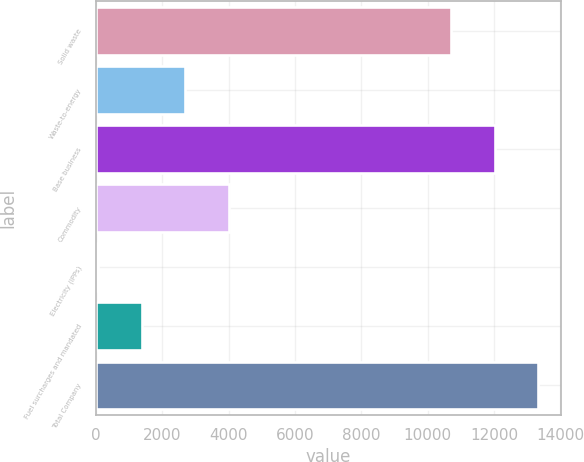Convert chart to OTSL. <chart><loc_0><loc_0><loc_500><loc_500><bar_chart><fcel>Solid waste<fcel>Waste-to-energy<fcel>Base business<fcel>Commodity<fcel>Electricity (IPPs)<fcel>Fuel surcharges and mandated<fcel>Total Company<nl><fcel>10715<fcel>2695.2<fcel>12025.6<fcel>4005.8<fcel>74<fcel>1384.6<fcel>13336.2<nl></chart> 